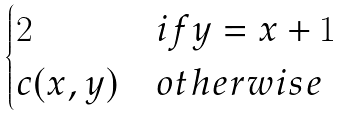<formula> <loc_0><loc_0><loc_500><loc_500>\begin{cases} 2 & i f y = x + 1 \\ c ( x , y ) & o t h e r w i s e \end{cases}</formula> 